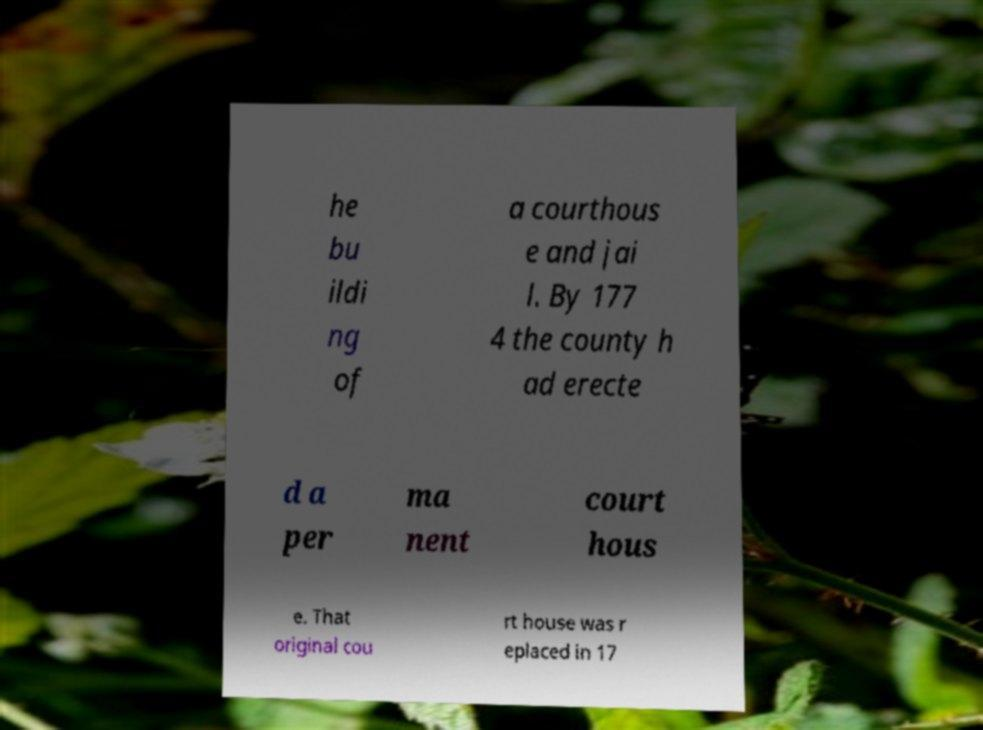There's text embedded in this image that I need extracted. Can you transcribe it verbatim? he bu ildi ng of a courthous e and jai l. By 177 4 the county h ad erecte d a per ma nent court hous e. That original cou rt house was r eplaced in 17 